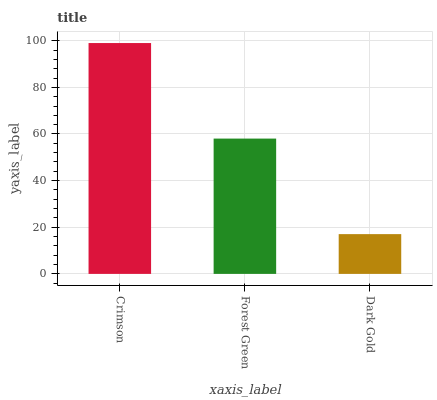Is Forest Green the minimum?
Answer yes or no. No. Is Forest Green the maximum?
Answer yes or no. No. Is Crimson greater than Forest Green?
Answer yes or no. Yes. Is Forest Green less than Crimson?
Answer yes or no. Yes. Is Forest Green greater than Crimson?
Answer yes or no. No. Is Crimson less than Forest Green?
Answer yes or no. No. Is Forest Green the high median?
Answer yes or no. Yes. Is Forest Green the low median?
Answer yes or no. Yes. Is Dark Gold the high median?
Answer yes or no. No. Is Crimson the low median?
Answer yes or no. No. 